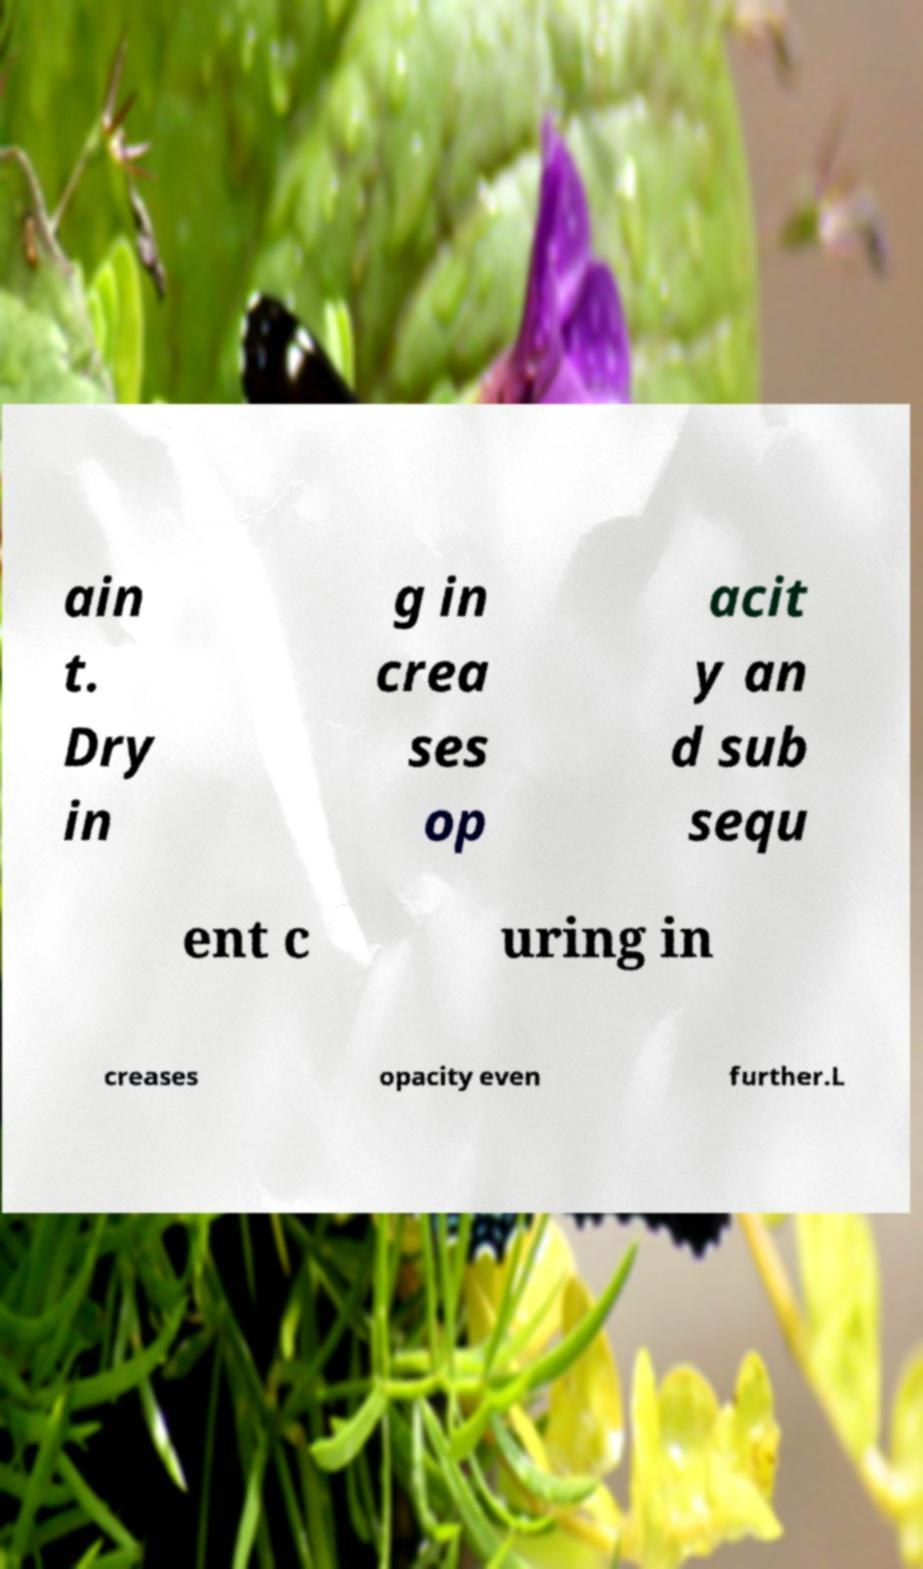Can you accurately transcribe the text from the provided image for me? ain t. Dry in g in crea ses op acit y an d sub sequ ent c uring in creases opacity even further.L 